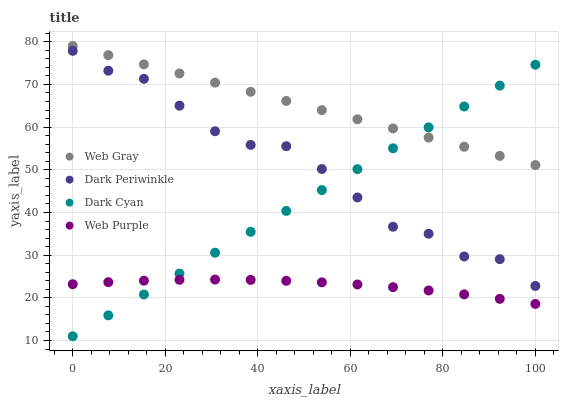Does Web Purple have the minimum area under the curve?
Answer yes or no. Yes. Does Web Gray have the maximum area under the curve?
Answer yes or no. Yes. Does Web Gray have the minimum area under the curve?
Answer yes or no. No. Does Web Purple have the maximum area under the curve?
Answer yes or no. No. Is Web Gray the smoothest?
Answer yes or no. Yes. Is Dark Periwinkle the roughest?
Answer yes or no. Yes. Is Web Purple the smoothest?
Answer yes or no. No. Is Web Purple the roughest?
Answer yes or no. No. Does Dark Cyan have the lowest value?
Answer yes or no. Yes. Does Web Purple have the lowest value?
Answer yes or no. No. Does Web Gray have the highest value?
Answer yes or no. Yes. Does Web Purple have the highest value?
Answer yes or no. No. Is Web Purple less than Dark Periwinkle?
Answer yes or no. Yes. Is Web Gray greater than Web Purple?
Answer yes or no. Yes. Does Web Gray intersect Dark Cyan?
Answer yes or no. Yes. Is Web Gray less than Dark Cyan?
Answer yes or no. No. Is Web Gray greater than Dark Cyan?
Answer yes or no. No. Does Web Purple intersect Dark Periwinkle?
Answer yes or no. No. 